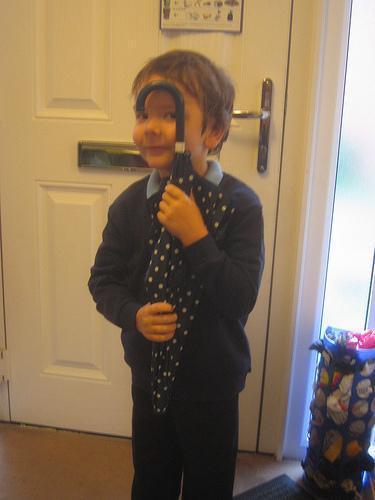How many people are there?
Give a very brief answer. 1. 